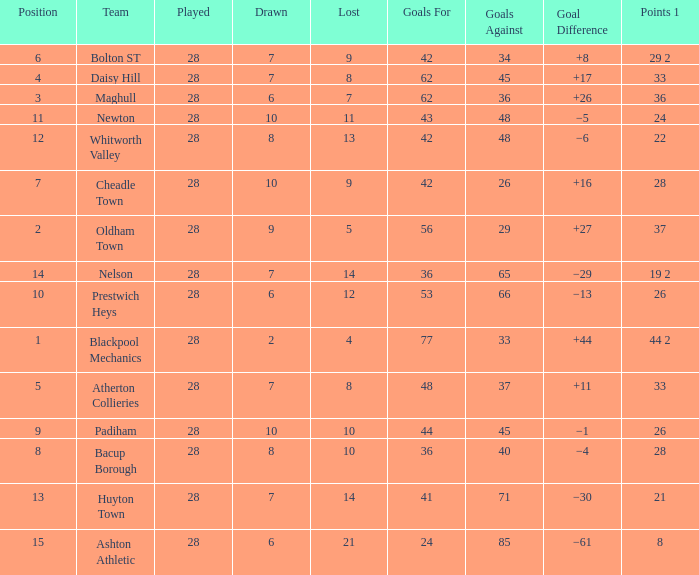What is the highest goals entry with drawn larger than 6 and goals against 85? None. 